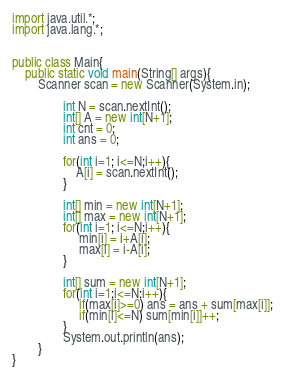Convert code to text. <code><loc_0><loc_0><loc_500><loc_500><_Java_>import java.util.*; 
import java.lang.*; 


public class Main{
	public static void main(String[] args){
		Scanner scan = new Scanner(System.in);
                
                int N = scan.nextInt();
                int[] A = new int[N+1];
                int cnt = 0;
                int ans = 0;
                
                for(int i=1; i<=N;i++){
                    A[i] = scan.nextInt();
                }
                
                int[] min = new int[N+1];
                int[] max = new int[N+1];
                for(int i=1; i<=N;i++){
                     min[i] = i+A[i];
                     max[i] = i-A[i];
                }
                
                int[] sum = new int[N+1];
                for(int i=1;i<=N;i++){
                     if(max[i]>=0) ans = ans + sum[max[i]];
                     if(min[i]<=N) sum[min[i]]++;
                }
                System.out.println(ans);
        }
}
</code> 